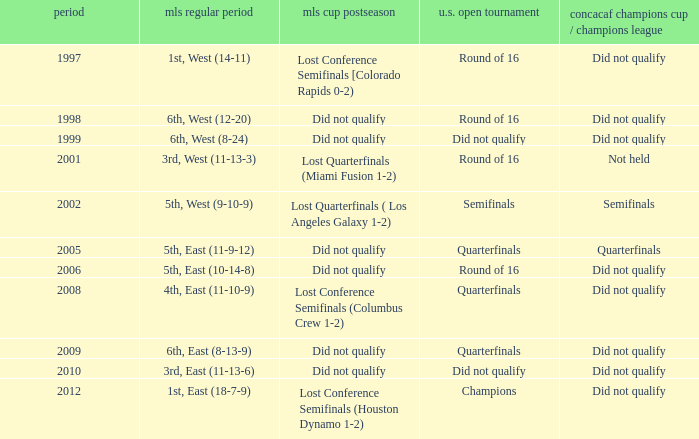How did the team place when they did not qualify for the Concaf Champions Cup but made it to Round of 16 in the U.S. Open Cup? Lost Conference Semifinals [Colorado Rapids 0-2), Did not qualify, Did not qualify. 